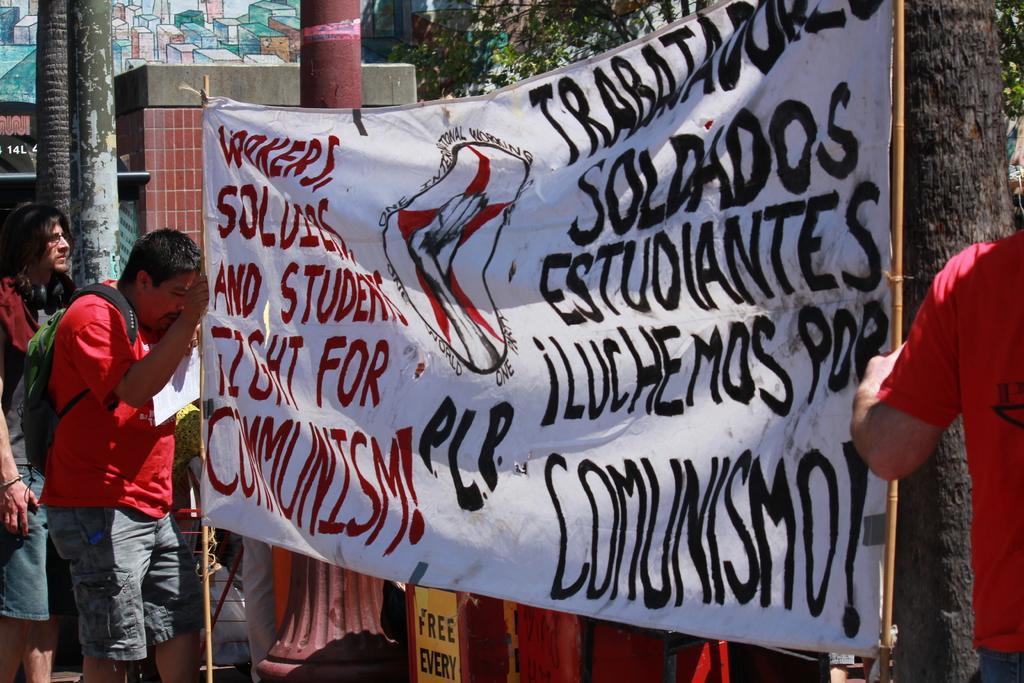Can you describe this image briefly? In the image in the center, we can see two persons are standing and holding a sign board. In the background, we can see trees, buildings, poles, banners and few people are standing. 